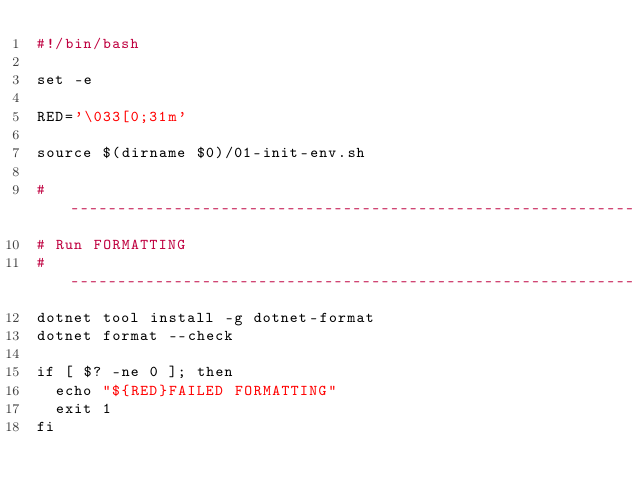Convert code to text. <code><loc_0><loc_0><loc_500><loc_500><_Bash_>#!/bin/bash

set -e

RED='\033[0;31m'

source $(dirname $0)/01-init-env.sh

#-------------------------------------------------------------------------------
# Run FORMATTING  
#-------------------------------------------------------------------------------
dotnet tool install -g dotnet-format
dotnet format --check

if [ $? -ne 0 ]; then
  echo "${RED}FAILED FORMATTING"
  exit 1
fi</code> 